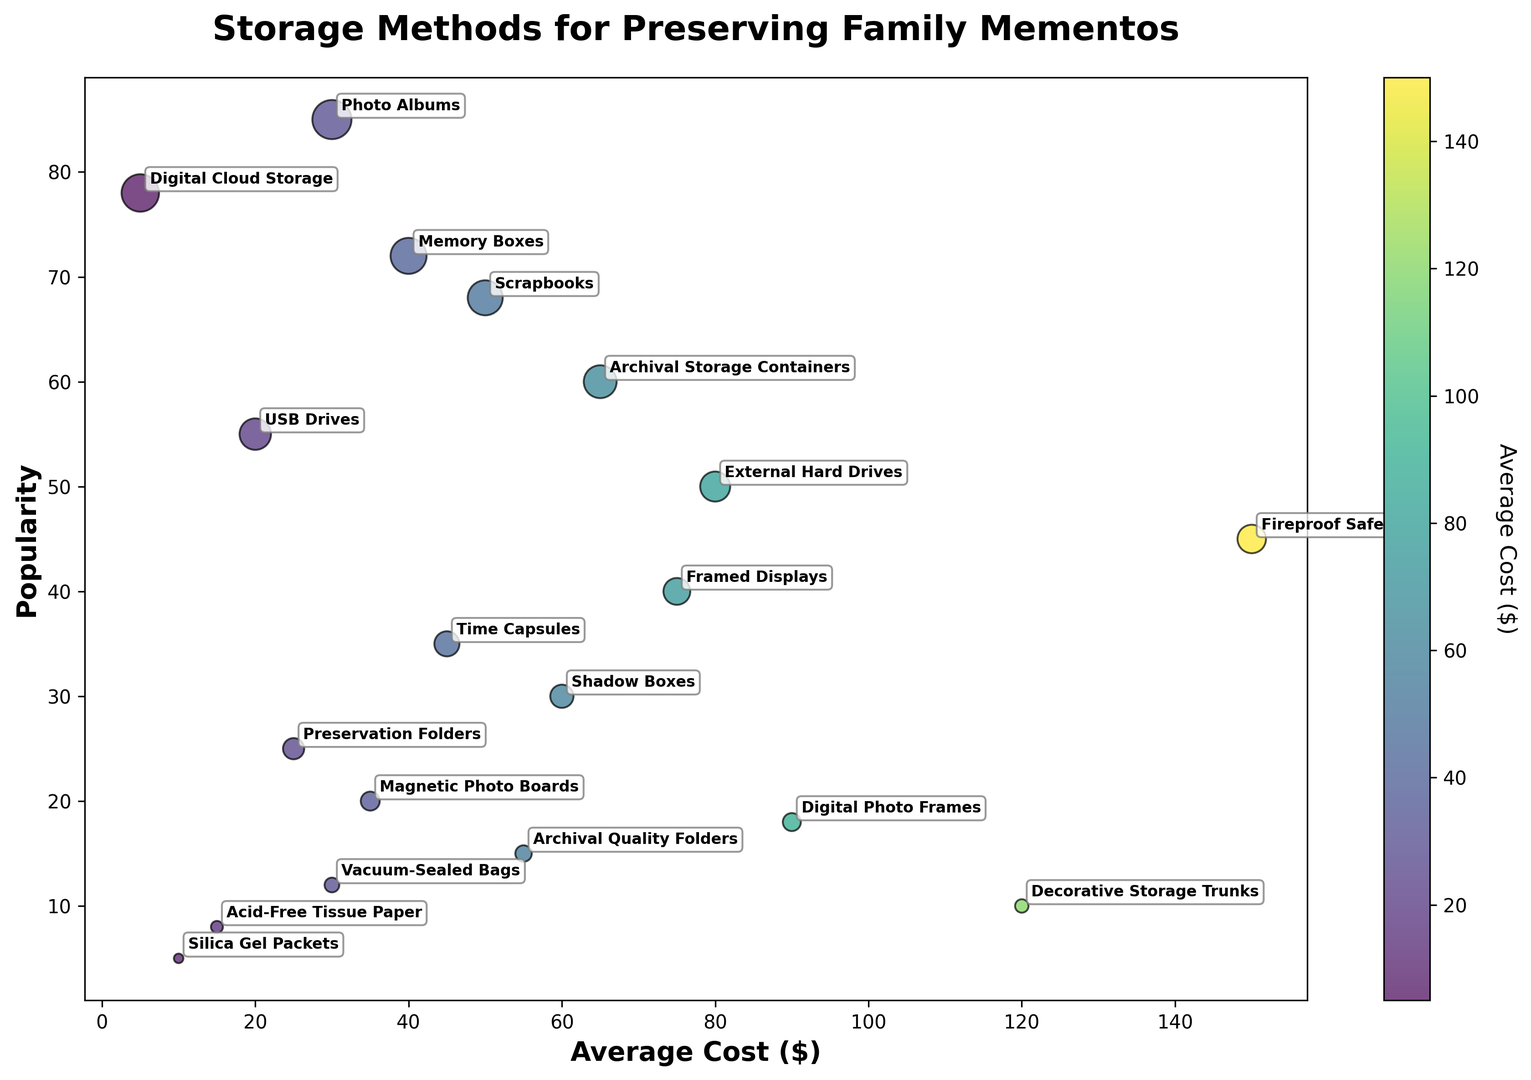What's the most popular storage method for preserving family mementos? The bubble with the highest position along the "Popularity" axis represents the most popular storage method, which is "Photo Albums" located at 85 popularity.
Answer: Photo Albums Which storage method has the highest average cost? Identify the bubble farthest to the right along the "Average Cost" axis; it represents "Fireproof Safes" with an average cost of $150.
Answer: Fireproof Safes What's the least popular storage method that costs less than $20 on average? First, look for bubbles with "Average Cost" values less than $20. Among these, the one lowest on the "Popularity" axis is "Silica Gel Packets" with 5 popularity.
Answer: Silica Gel Packets For storage methods with an average cost of $50 to $80, which one is more popular: "Scrapbooks" or "External Hard Drives"? Identify the bubbles within the $50 to $80 cost range. "Scrapbooks" have a popularity of 68, while "External Hard Drives" have a popularity of 50. Therefore, "Scrapbooks" are more popular.
Answer: Scrapbooks What are the average cost and popularity for "Time Capsules"? Locate the bubble labeled "Time Capsules" and read its position; it is at $45 for average cost and 35 for popularity.
Answer: $45, 35 Do "Archival Storage Containers" have a higher or lower average cost compared to "Scrapbooks"? Compare their positions on the "Average Cost" axis: "Archival Storage Containers" at $65 and "Scrapbooks" at $50.
Answer: Higher Which storage method with a popularity greater than 60 has the lowest average cost? Identify bubbles with popularity over 60. Among them, "Digital Cloud Storage" has the lowest average cost of $5.
Answer: Digital Cloud Storage How many storage methods have an average cost below $50? Count the bubbles to the left of the $50 mark on the "Average Cost" axis, there are 6 of them.
Answer: 6 Compare the popularity of "Framed Displays" and "Shadow Boxes". Which one is more popular? Locate both bubbles and compare their positions along the "Popularity" axis. "Framed Displays" are at 40, and "Shadow Boxes" are at 30. Thus, "Framed Displays" are more popular.
Answer: Framed Displays What’s the difference in popularity between the storage method with the highest average cost and the one with the lowest average cost? Find "Fireproof Safes" (highest average cost, popularity 45) and "Digital Cloud Storage" (lowest average cost, popularity 78). The difference is 78 - 45 = 33.
Answer: 33 